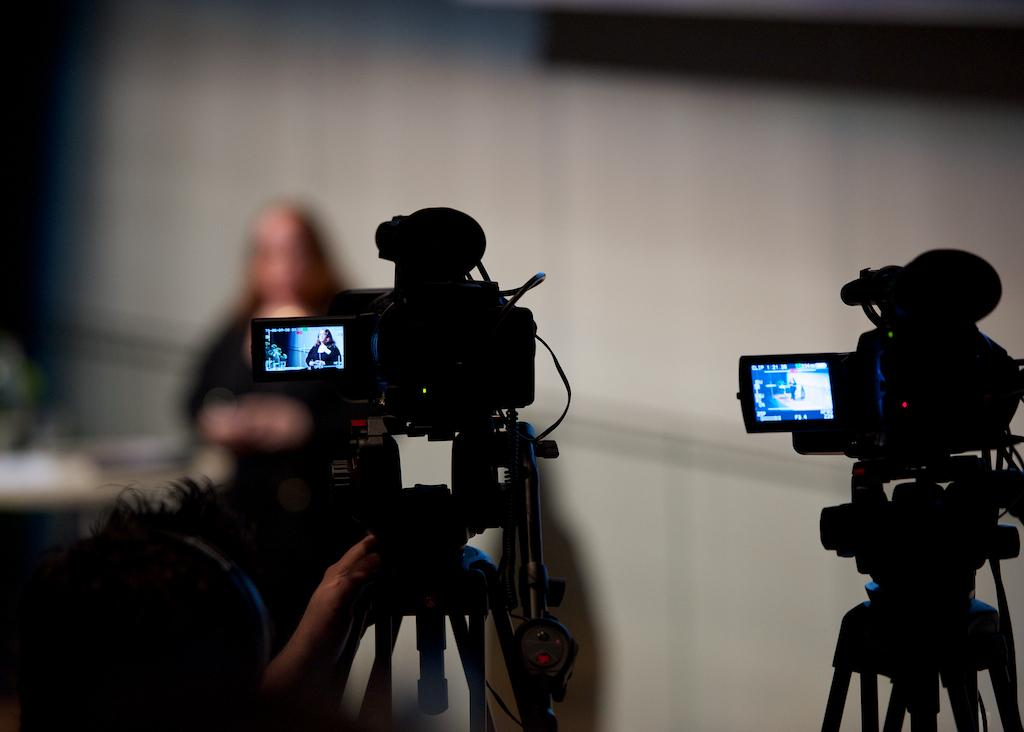What objects are being held by the person in the image? The person is holding two cameras in the image. Can you describe the person's action in the image? The person is holding the cameras. What else can be seen in the background of the image? There is a woman in the background of the image. What type of nut is being used to adjust the settings on the cameras in the image? There is no nut present in the image, and the cameras' settings are not being adjusted. 